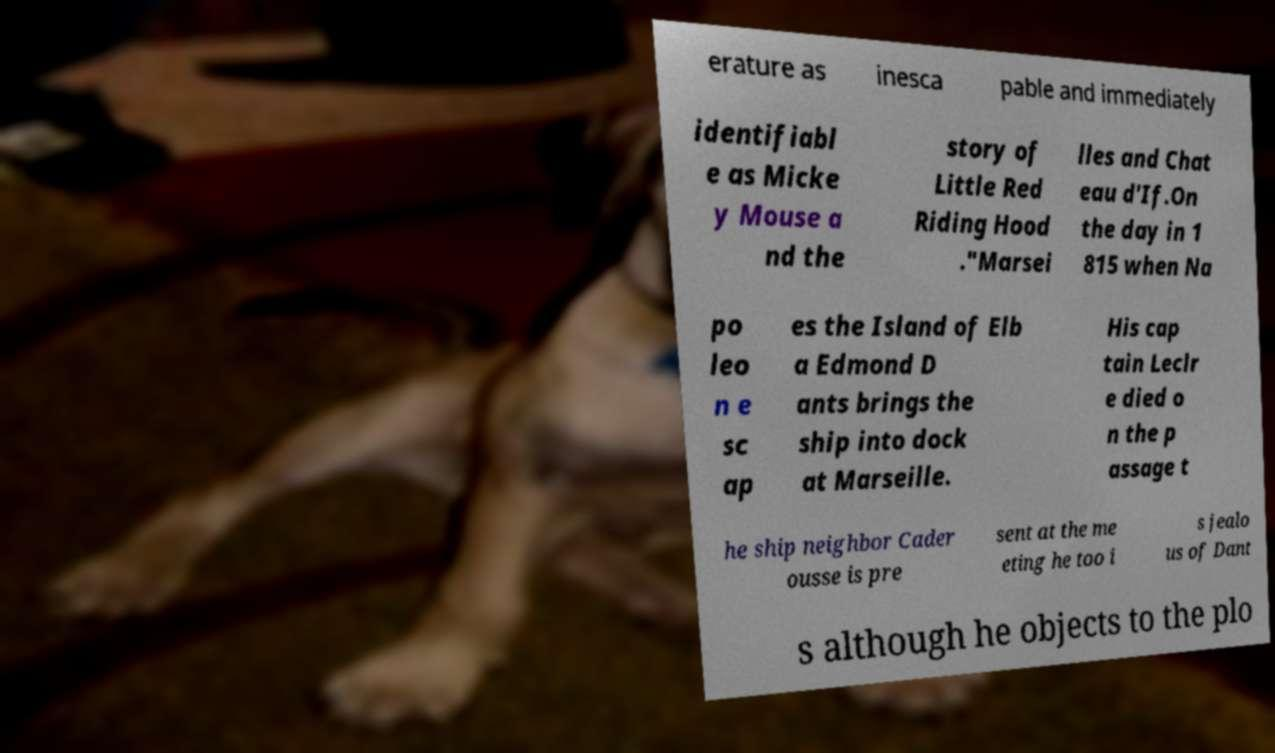What messages or text are displayed in this image? I need them in a readable, typed format. erature as inesca pable and immediately identifiabl e as Micke y Mouse a nd the story of Little Red Riding Hood ."Marsei lles and Chat eau d'If.On the day in 1 815 when Na po leo n e sc ap es the Island of Elb a Edmond D ants brings the ship into dock at Marseille. His cap tain Leclr e died o n the p assage t he ship neighbor Cader ousse is pre sent at the me eting he too i s jealo us of Dant s although he objects to the plo 